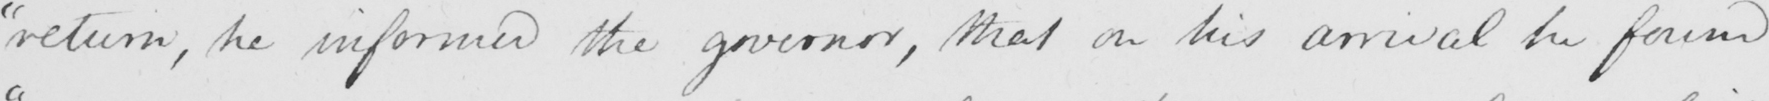Can you read and transcribe this handwriting? " return he informed the governor , that on his arrival he found 